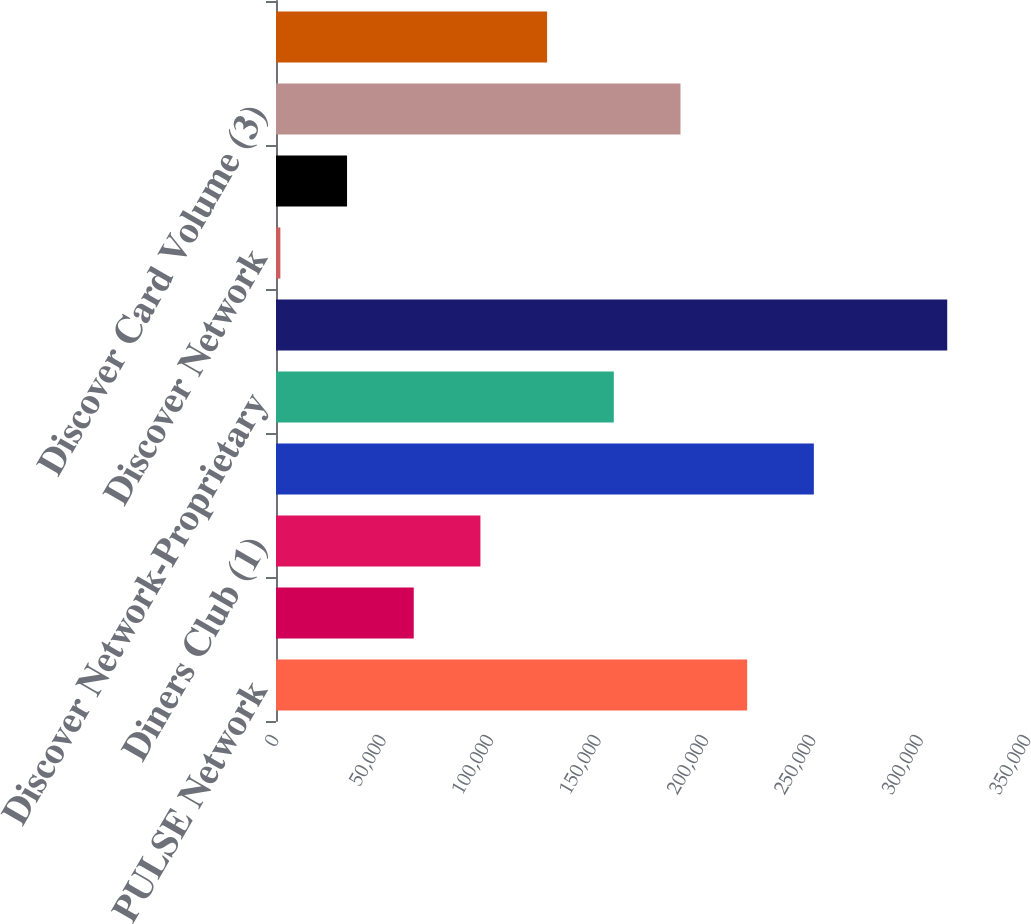Convert chart to OTSL. <chart><loc_0><loc_0><loc_500><loc_500><bar_chart><fcel>PULSE Network<fcel>Network Partners<fcel>Diners Club (1)<fcel>Total Payment Services<fcel>Discover Network-Proprietary<fcel>Total Volume<fcel>Discover Network<fcel>Total<fcel>Discover Card Volume (3)<fcel>Discover Card Sales Volume (4)<nl><fcel>219292<fcel>64107<fcel>95144<fcel>250329<fcel>157218<fcel>312403<fcel>2033<fcel>33070<fcel>188255<fcel>126181<nl></chart> 